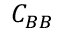<formula> <loc_0><loc_0><loc_500><loc_500>C _ { B B }</formula> 